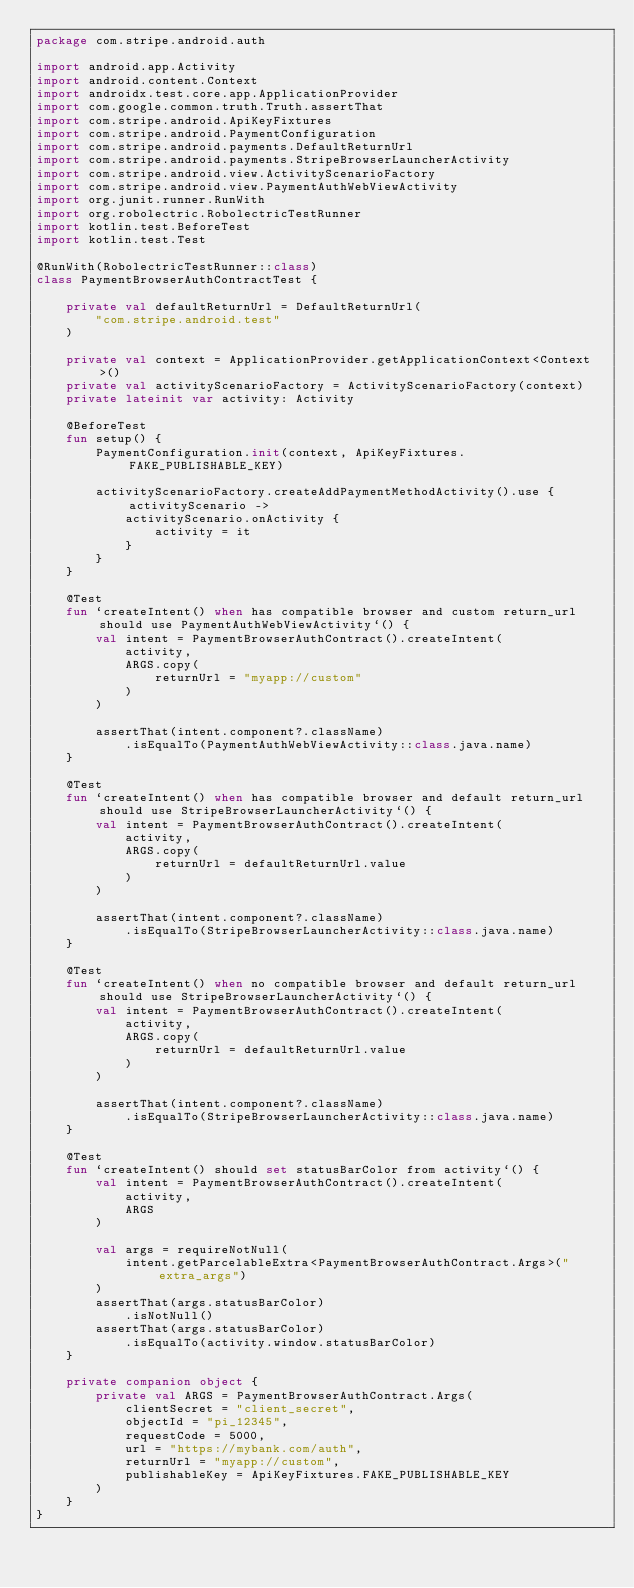Convert code to text. <code><loc_0><loc_0><loc_500><loc_500><_Kotlin_>package com.stripe.android.auth

import android.app.Activity
import android.content.Context
import androidx.test.core.app.ApplicationProvider
import com.google.common.truth.Truth.assertThat
import com.stripe.android.ApiKeyFixtures
import com.stripe.android.PaymentConfiguration
import com.stripe.android.payments.DefaultReturnUrl
import com.stripe.android.payments.StripeBrowserLauncherActivity
import com.stripe.android.view.ActivityScenarioFactory
import com.stripe.android.view.PaymentAuthWebViewActivity
import org.junit.runner.RunWith
import org.robolectric.RobolectricTestRunner
import kotlin.test.BeforeTest
import kotlin.test.Test

@RunWith(RobolectricTestRunner::class)
class PaymentBrowserAuthContractTest {

    private val defaultReturnUrl = DefaultReturnUrl(
        "com.stripe.android.test"
    )

    private val context = ApplicationProvider.getApplicationContext<Context>()
    private val activityScenarioFactory = ActivityScenarioFactory(context)
    private lateinit var activity: Activity

    @BeforeTest
    fun setup() {
        PaymentConfiguration.init(context, ApiKeyFixtures.FAKE_PUBLISHABLE_KEY)

        activityScenarioFactory.createAddPaymentMethodActivity().use { activityScenario ->
            activityScenario.onActivity {
                activity = it
            }
        }
    }

    @Test
    fun `createIntent() when has compatible browser and custom return_url should use PaymentAuthWebViewActivity`() {
        val intent = PaymentBrowserAuthContract().createIntent(
            activity,
            ARGS.copy(
                returnUrl = "myapp://custom"
            )
        )

        assertThat(intent.component?.className)
            .isEqualTo(PaymentAuthWebViewActivity::class.java.name)
    }

    @Test
    fun `createIntent() when has compatible browser and default return_url should use StripeBrowserLauncherActivity`() {
        val intent = PaymentBrowserAuthContract().createIntent(
            activity,
            ARGS.copy(
                returnUrl = defaultReturnUrl.value
            )
        )

        assertThat(intent.component?.className)
            .isEqualTo(StripeBrowserLauncherActivity::class.java.name)
    }

    @Test
    fun `createIntent() when no compatible browser and default return_url should use StripeBrowserLauncherActivity`() {
        val intent = PaymentBrowserAuthContract().createIntent(
            activity,
            ARGS.copy(
                returnUrl = defaultReturnUrl.value
            )
        )

        assertThat(intent.component?.className)
            .isEqualTo(StripeBrowserLauncherActivity::class.java.name)
    }

    @Test
    fun `createIntent() should set statusBarColor from activity`() {
        val intent = PaymentBrowserAuthContract().createIntent(
            activity,
            ARGS
        )

        val args = requireNotNull(
            intent.getParcelableExtra<PaymentBrowserAuthContract.Args>("extra_args")
        )
        assertThat(args.statusBarColor)
            .isNotNull()
        assertThat(args.statusBarColor)
            .isEqualTo(activity.window.statusBarColor)
    }

    private companion object {
        private val ARGS = PaymentBrowserAuthContract.Args(
            clientSecret = "client_secret",
            objectId = "pi_12345",
            requestCode = 5000,
            url = "https://mybank.com/auth",
            returnUrl = "myapp://custom",
            publishableKey = ApiKeyFixtures.FAKE_PUBLISHABLE_KEY
        )
    }
}
</code> 